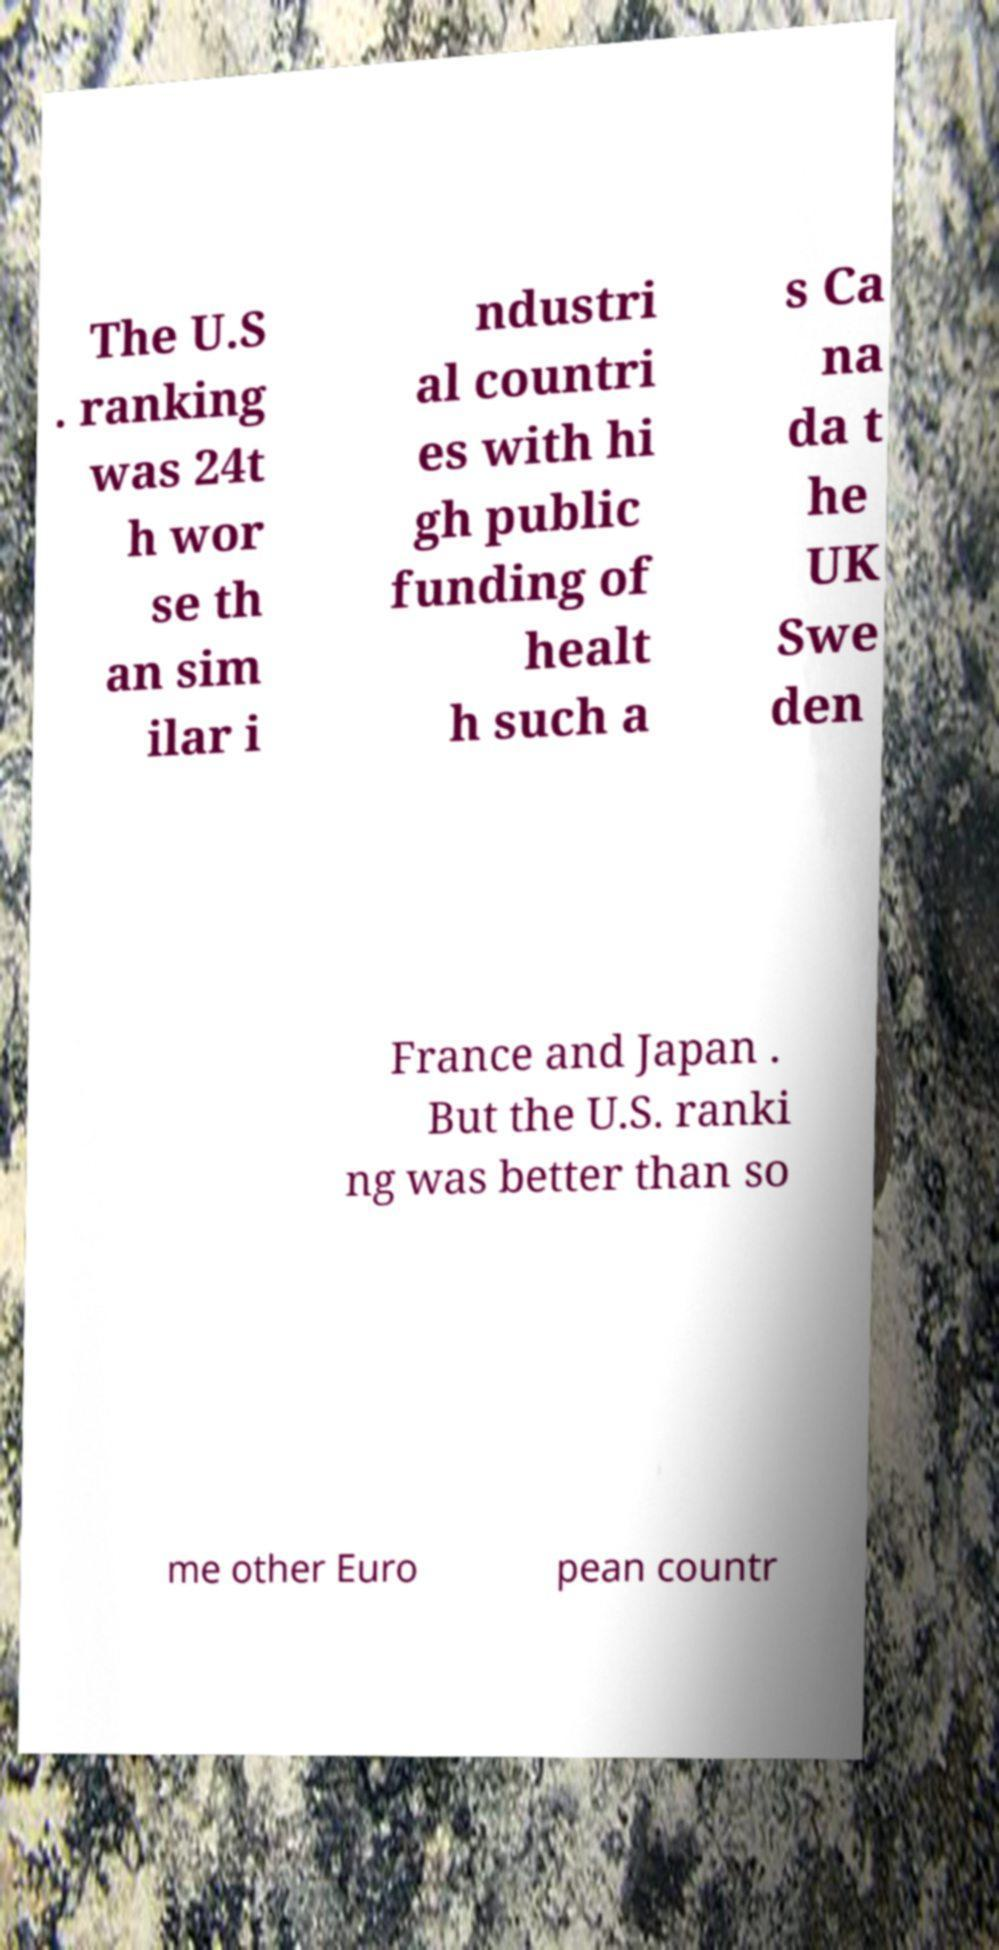For documentation purposes, I need the text within this image transcribed. Could you provide that? The U.S . ranking was 24t h wor se th an sim ilar i ndustri al countri es with hi gh public funding of healt h such a s Ca na da t he UK Swe den France and Japan . But the U.S. ranki ng was better than so me other Euro pean countr 